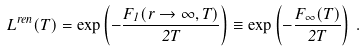<formula> <loc_0><loc_0><loc_500><loc_500>L ^ { r e n } ( T ) = \exp \left ( - \frac { F _ { 1 } ( r \rightarrow \infty , T ) } { 2 T } \right ) \equiv \exp \left ( - \frac { F _ { \infty } ( T ) } { 2 T } \right ) \, .</formula> 